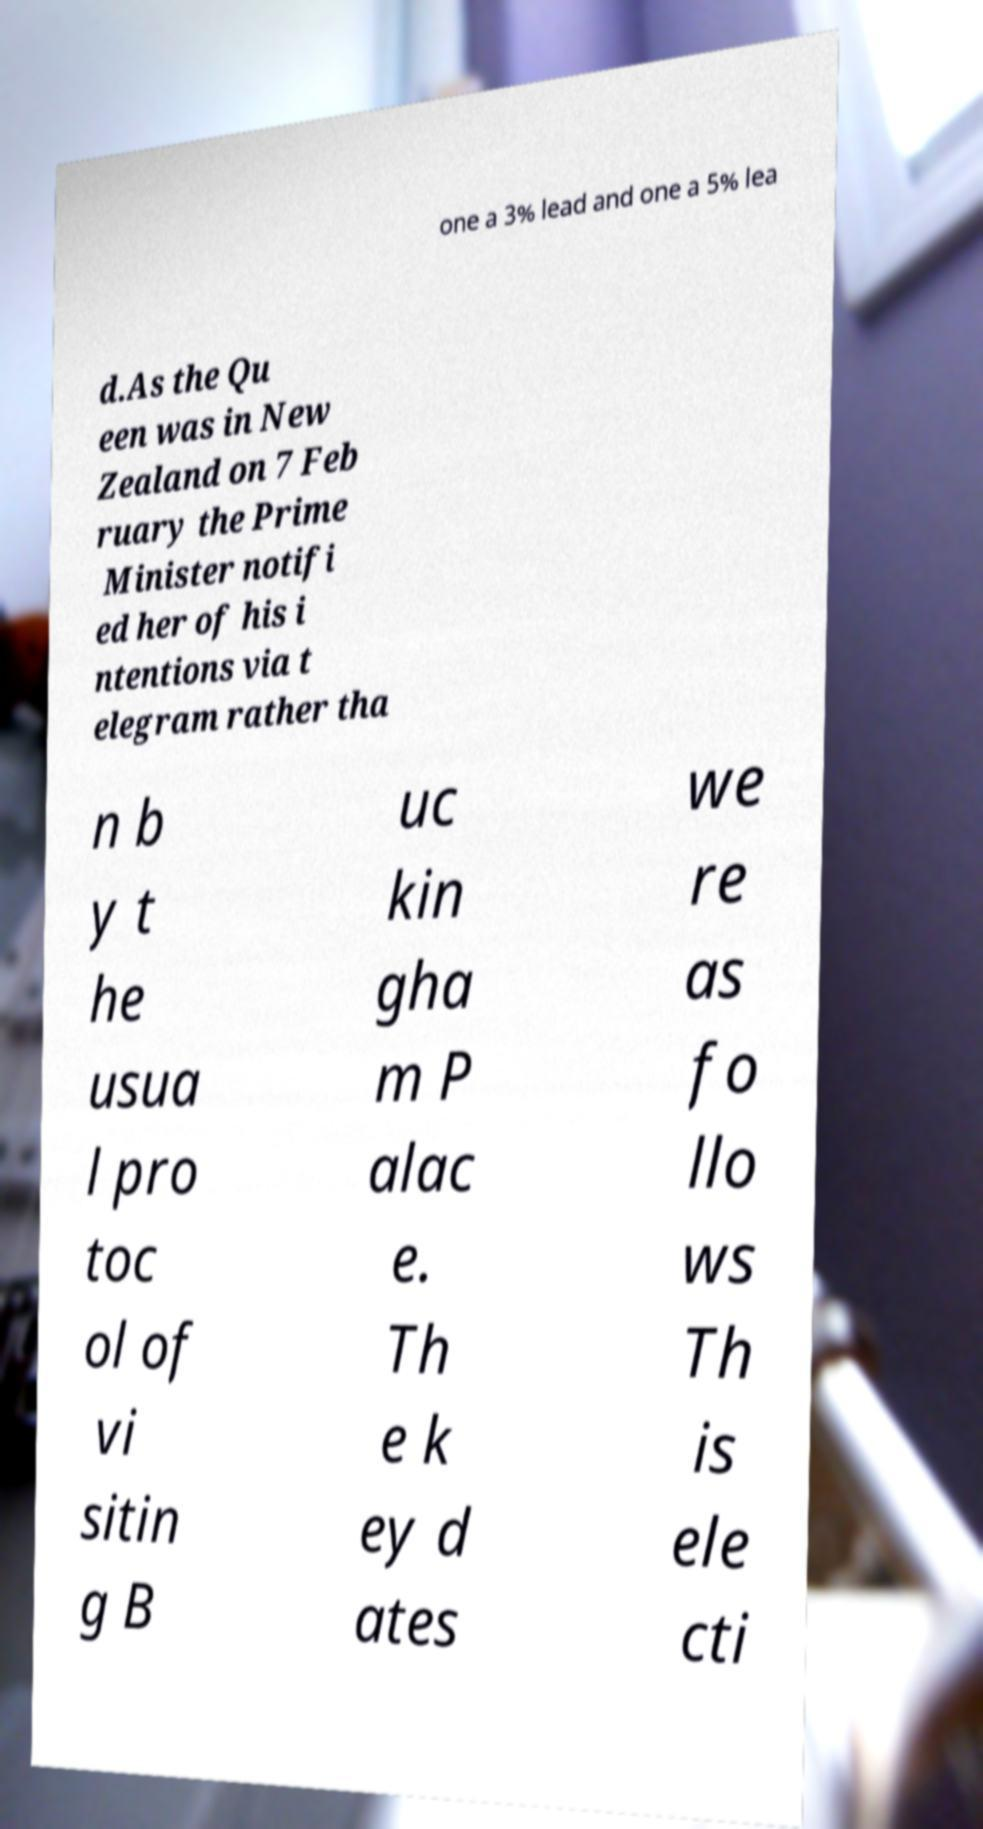Could you extract and type out the text from this image? one a 3% lead and one a 5% lea d.As the Qu een was in New Zealand on 7 Feb ruary the Prime Minister notifi ed her of his i ntentions via t elegram rather tha n b y t he usua l pro toc ol of vi sitin g B uc kin gha m P alac e. Th e k ey d ates we re as fo llo ws Th is ele cti 